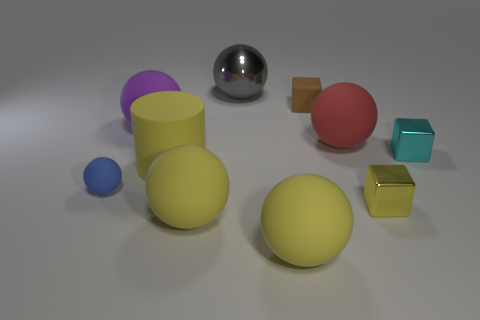Subtract all purple balls. How many balls are left? 5 Subtract all red matte balls. How many balls are left? 5 Subtract all purple spheres. Subtract all gray cubes. How many spheres are left? 5 Subtract all balls. How many objects are left? 4 Add 1 gray metallic balls. How many gray metallic balls are left? 2 Add 8 tiny yellow metal objects. How many tiny yellow metal objects exist? 9 Subtract 0 brown spheres. How many objects are left? 10 Subtract all gray metallic cubes. Subtract all yellow metallic blocks. How many objects are left? 9 